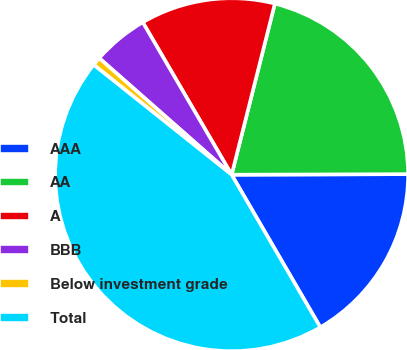Convert chart. <chart><loc_0><loc_0><loc_500><loc_500><pie_chart><fcel>AAA<fcel>AA<fcel>A<fcel>BBB<fcel>Below investment grade<fcel>Total<nl><fcel>16.67%<fcel>21.01%<fcel>12.34%<fcel>5.11%<fcel>0.78%<fcel>44.09%<nl></chart> 